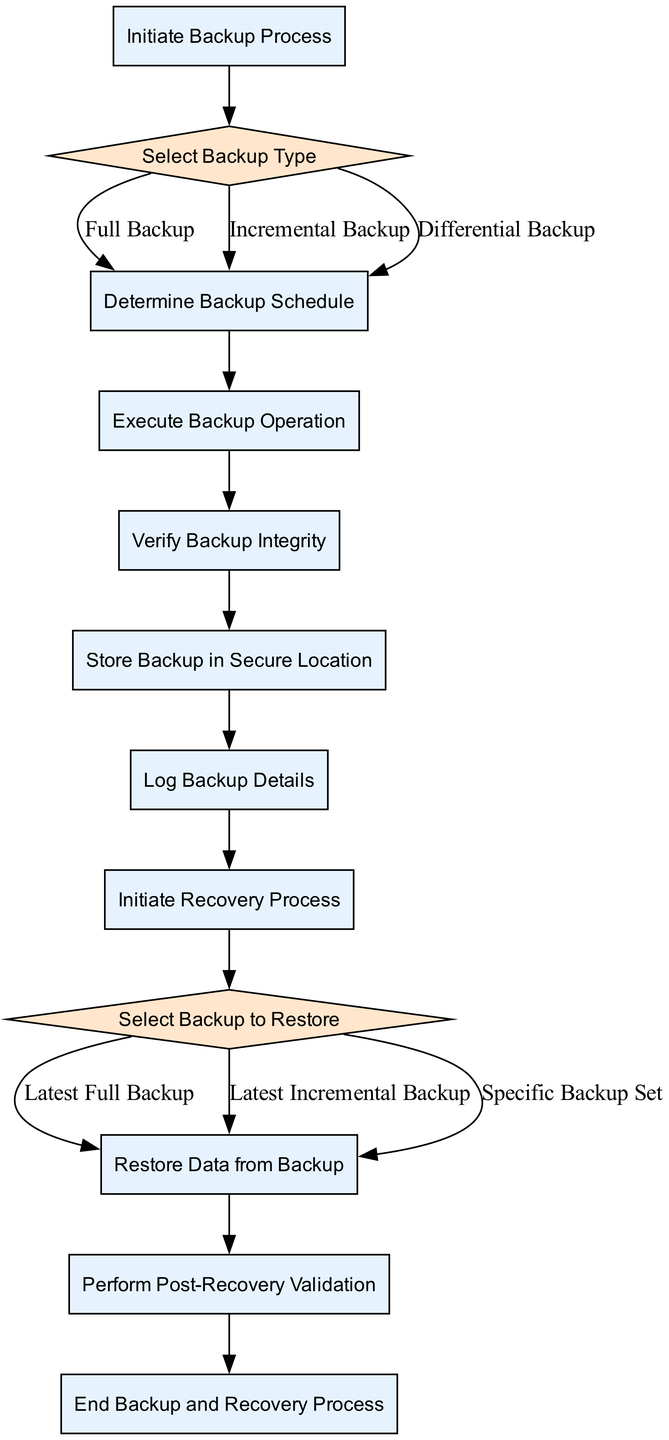What is the first step in the diagram? The first node in the flow chart is labeled "Initiate Backup Process," which signifies the start of the backup and recovery process.
Answer: Initiate Backup Process How many types of backup can be selected? The decision node "Select Backup Type" lists three options: Full Backup, Incremental Backup, and Differential Backup, indicating a total of three options available.
Answer: Three What comes after "Execute Backup Operation"? Following the "Execute Backup Operation" process node, the next step indicated in the diagram is "Verify Backup Integrity." This establishes the flow from executing to verifying the backup.
Answer: Verify Backup Integrity Which node follows "Choose Backup"? After making the decision at "Choose Backup," whether for Latest Full Backup, Latest Incremental Backup, or Specific Backup Set, the flow leads directly to "Restore Data from Backup." This indicates that restoration follows the selection of the backup type.
Answer: Restore Data from Backup During the recovery process, what is the last action taken? The final process node in the recovery flow is "End Backup and Recovery Process," which indicates the conclusion of all operations after validations are complete.
Answer: End Backup and Recovery Process What type of backup is verified after execution? The process "Verify Backup Integrity" specifically follows the "Execute Backup Operation," meaning the integrity verification directly concerns the backup that has just been executed.
Answer: Backup Integrity If a full backup is chosen, what will be the next node? If a "Full Backup" is selected in the "Select Backup Type" decision node, the flow proceeds to the "Determine Backup Schedule," representing the next step in planning the backup process.
Answer: Determine Backup Schedule How many edges connect to the "Store Backup in Secure Location" node? The "Store Backup in Secure Location" process is connected by a single edge leading from the previous node "Verify Backup Integrity," indicating the progression is direct without alternative pathways at this point.
Answer: One 